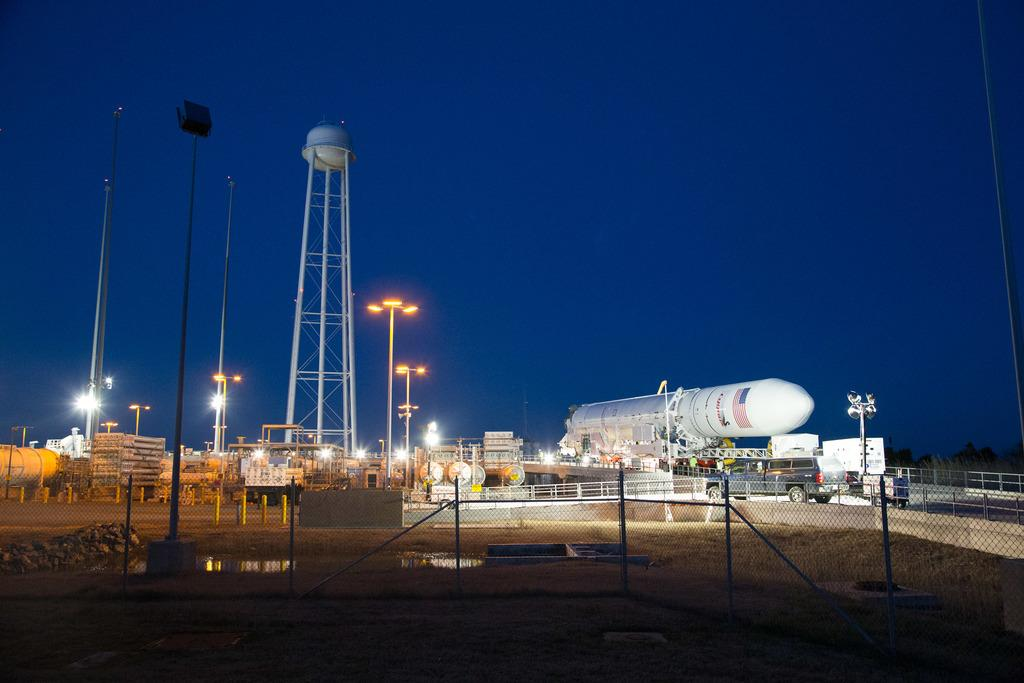What is located on the right side of the image? There is a rocket on the right side of the image. What can be seen on the left side of the image? There are poles on the left side of the image. What is the purpose of the net boundary at the bottom side of the image? The net boundary at the bottom side of the image is likely used to contain or separate objects or areas. Can you tell me how many caves are visible in the image? There are no caves present in the image. What type of haircut does the rocket have in the image? The rocket does not have a haircut, as it is an inanimate object. 